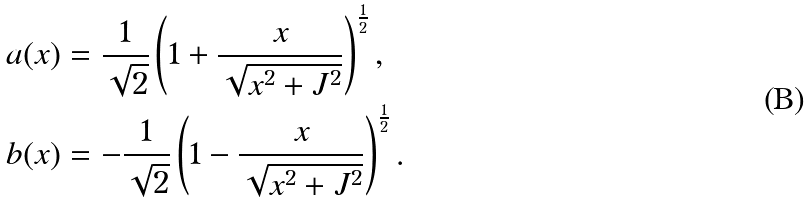Convert formula to latex. <formula><loc_0><loc_0><loc_500><loc_500>& a ( x ) = \frac { 1 } { \sqrt { 2 } } \left ( 1 + \frac { x } { \sqrt { x ^ { 2 } + J ^ { 2 } } } \right ) ^ { \frac { 1 } { 2 } } , \\ & b ( x ) = - \frac { 1 } { \sqrt { 2 } } \left ( 1 - \frac { x } { \sqrt { x ^ { 2 } + J ^ { 2 } } } \right ) ^ { \frac { 1 } { 2 } } .</formula> 